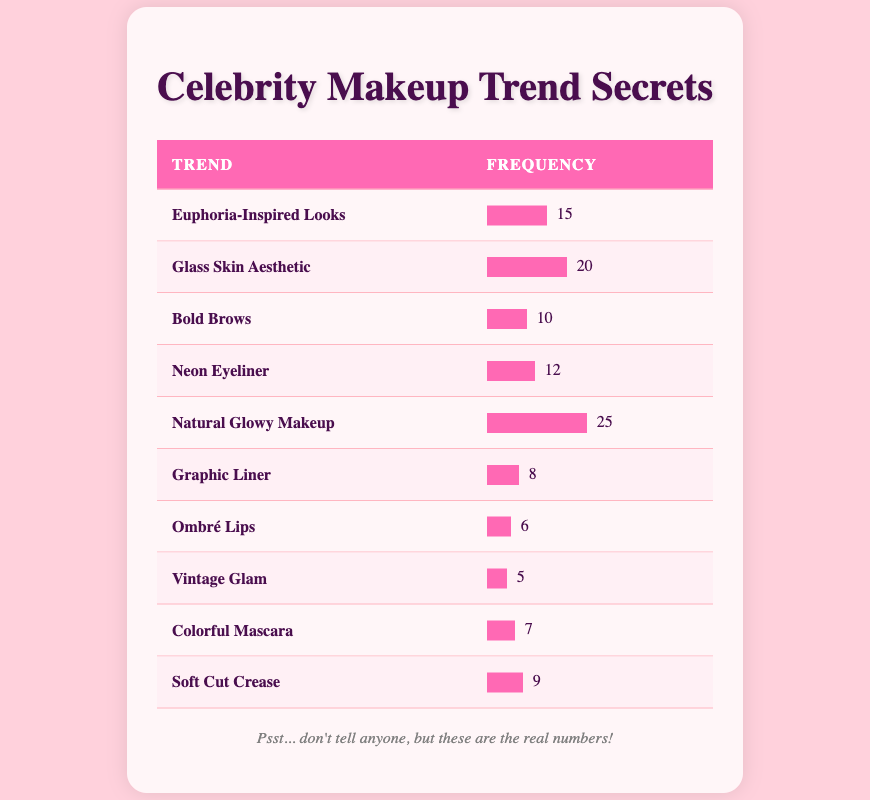What is the most requested makeup trend? The trend with the highest frequency in the table is "Natural Glowy Makeup," which has a frequency of 25.
Answer: Natural Glowy Makeup How many clients requested "Graphic Liner"? The frequency for "Graphic Liner" in the table is 8, indicating that 8 clients requested this makeup look.
Answer: 8 Which two trends have the lowest frequencies? The trends with the lowest frequencies are "Vintage Glam" with 5 requests and "Ombré Lips" with 6 requests.
Answer: Vintage Glam and Ombré Lips Is "Neon Eyeliner" more popular than "Euphoria-Inspired Looks"? "Neon Eyeliner" has a frequency of 12, while "Euphoria-Inspired Looks" has a frequency of 15, indicating that "Euphoria-Inspired Looks" is more popular.
Answer: No What is the average frequency of requests for the top three trends? The top three trends by frequency are "Natural Glowy Makeup" (25), "Glass Skin Aesthetic" (20), and "Euphoria-Inspired Looks" (15). Their total is 60; dividing by 3 gives an average of 20.
Answer: 20 How many total client requests were there for all makeup trends combined? To find the total, we add all the frequencies: 15 + 20 + 10 + 12 + 25 + 8 + 6 + 5 + 7 + 9 = 117.
Answer: 117 Which trend has a frequency that is exactly double that of "Graphic Liner"? "Bold Brows" has a frequency of 10, while "Graphic Liner" has a frequency of 8, and there is no trend with a frequency exactly double; however, "Natural Glowy Makeup" is more than double "Graphic Liner."
Answer: None What percentage of total requests did "Soft Cut Crease" receive? "Soft Cut Crease" has a frequency of 9. The total frequency is 117. To find the percentage: (9/117) * 100 = 7.69%.
Answer: 7.69% Which trend is the least requested according to the table? The least requested trend with the lowest frequency is "Vintage Glam," which has a frequency of 5.
Answer: Vintage Glam 